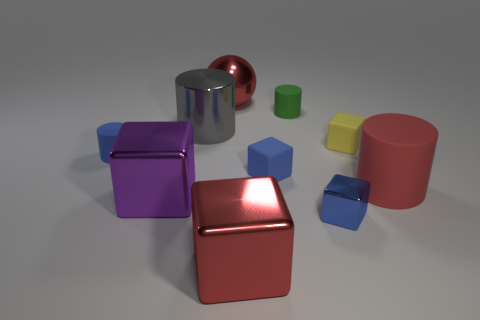Subtract all red cubes. How many cubes are left? 4 Subtract all small shiny cubes. How many cubes are left? 4 Subtract all purple cylinders. Subtract all cyan cubes. How many cylinders are left? 4 Subtract all balls. How many objects are left? 9 Add 7 purple things. How many purple things exist? 8 Subtract 0 green blocks. How many objects are left? 10 Subtract all tiny yellow cubes. Subtract all big red cylinders. How many objects are left? 8 Add 6 blue shiny things. How many blue shiny things are left? 7 